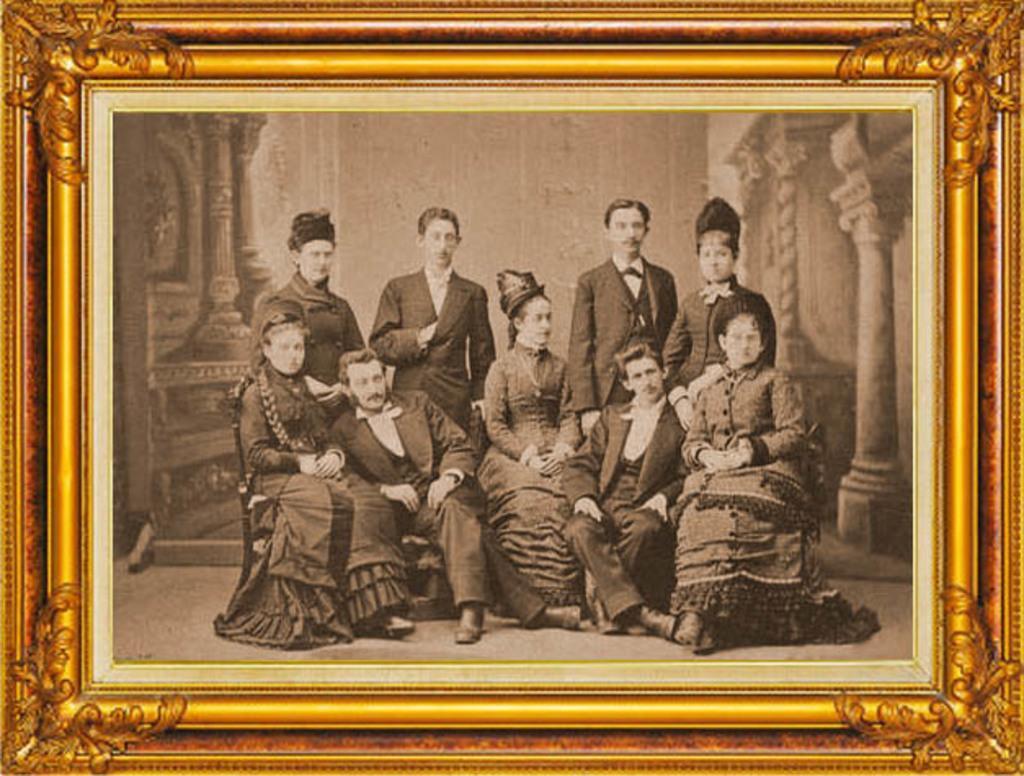In one or two sentences, can you explain what this image depicts? In this image there is a frame of a few people. 